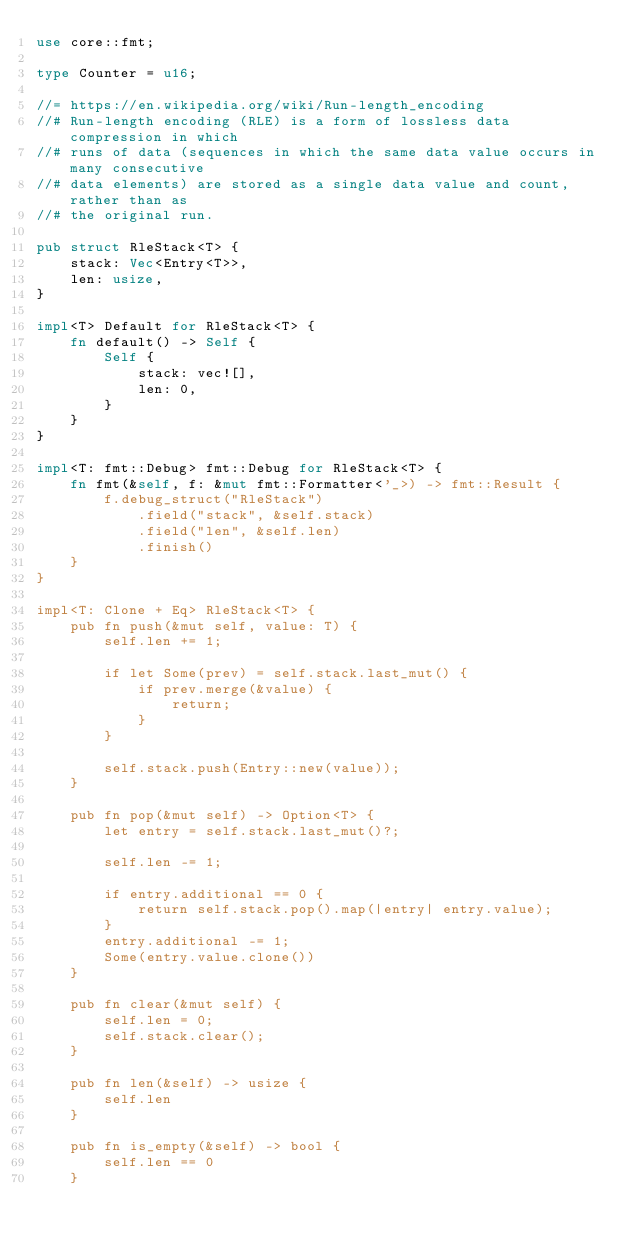Convert code to text. <code><loc_0><loc_0><loc_500><loc_500><_Rust_>use core::fmt;

type Counter = u16;

//= https://en.wikipedia.org/wiki/Run-length_encoding
//# Run-length encoding (RLE) is a form of lossless data compression in which
//# runs of data (sequences in which the same data value occurs in many consecutive
//# data elements) are stored as a single data value and count, rather than as
//# the original run.

pub struct RleStack<T> {
    stack: Vec<Entry<T>>,
    len: usize,
}

impl<T> Default for RleStack<T> {
    fn default() -> Self {
        Self {
            stack: vec![],
            len: 0,
        }
    }
}

impl<T: fmt::Debug> fmt::Debug for RleStack<T> {
    fn fmt(&self, f: &mut fmt::Formatter<'_>) -> fmt::Result {
        f.debug_struct("RleStack")
            .field("stack", &self.stack)
            .field("len", &self.len)
            .finish()
    }
}

impl<T: Clone + Eq> RleStack<T> {
    pub fn push(&mut self, value: T) {
        self.len += 1;

        if let Some(prev) = self.stack.last_mut() {
            if prev.merge(&value) {
                return;
            }
        }

        self.stack.push(Entry::new(value));
    }

    pub fn pop(&mut self) -> Option<T> {
        let entry = self.stack.last_mut()?;

        self.len -= 1;

        if entry.additional == 0 {
            return self.stack.pop().map(|entry| entry.value);
        }
        entry.additional -= 1;
        Some(entry.value.clone())
    }

    pub fn clear(&mut self) {
        self.len = 0;
        self.stack.clear();
    }

    pub fn len(&self) -> usize {
        self.len
    }

    pub fn is_empty(&self) -> bool {
        self.len == 0
    }
</code> 